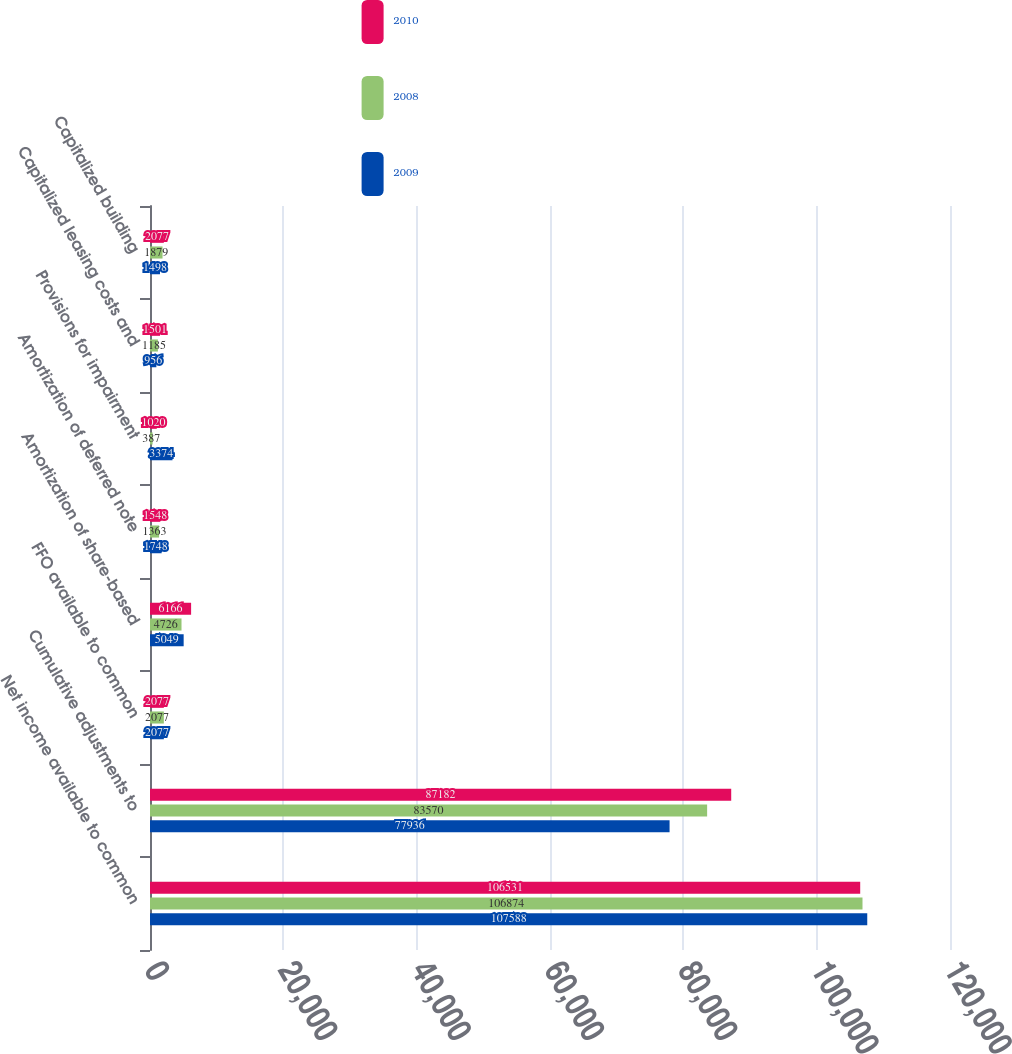<chart> <loc_0><loc_0><loc_500><loc_500><stacked_bar_chart><ecel><fcel>Net income available to common<fcel>Cumulative adjustments to<fcel>FFO available to common<fcel>Amortization of share-based<fcel>Amortization of deferred note<fcel>Provisions for impairment<fcel>Capitalized leasing costs and<fcel>Capitalized building<nl><fcel>2010<fcel>106531<fcel>87182<fcel>2077<fcel>6166<fcel>1548<fcel>1020<fcel>1501<fcel>2077<nl><fcel>2008<fcel>106874<fcel>83570<fcel>2077<fcel>4726<fcel>1363<fcel>387<fcel>1185<fcel>1879<nl><fcel>2009<fcel>107588<fcel>77936<fcel>2077<fcel>5049<fcel>1748<fcel>3374<fcel>956<fcel>1498<nl></chart> 